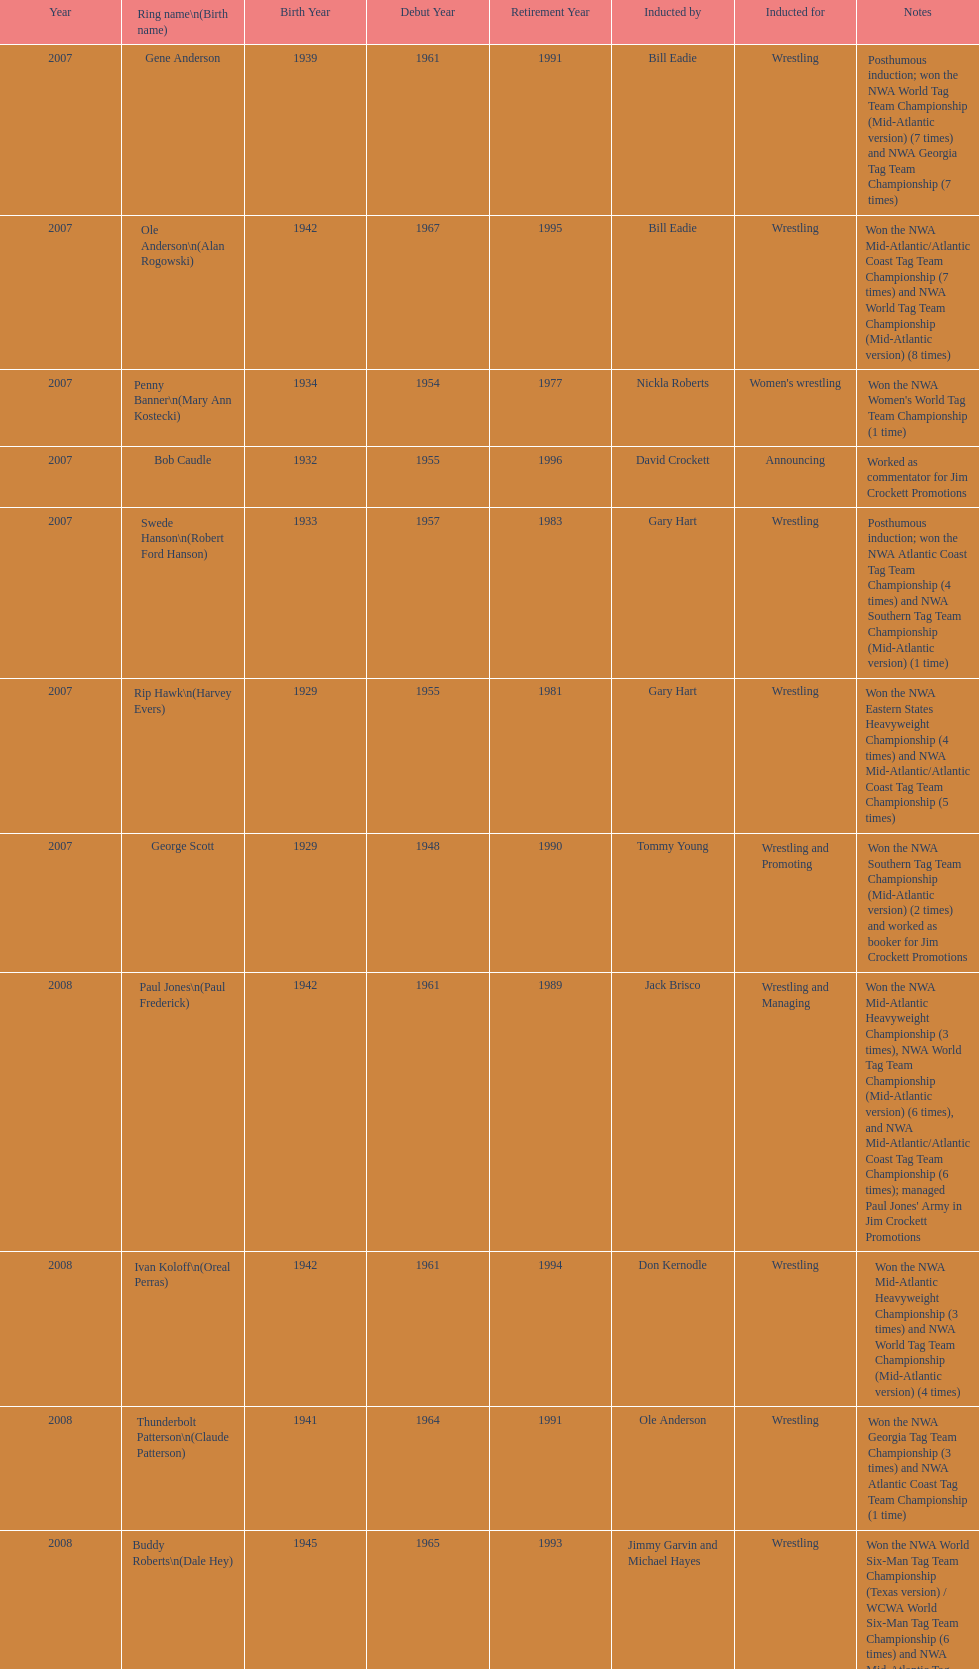Who's real name is dale hey, grizzly smith or buddy roberts? Buddy Roberts. 